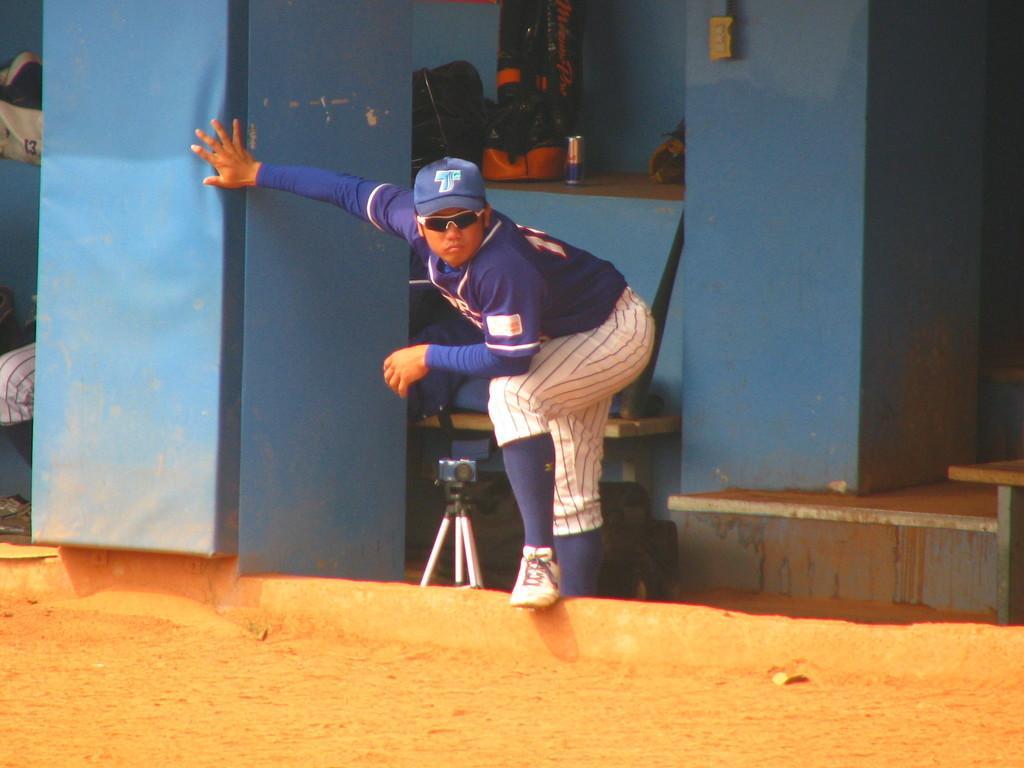Please provide a concise description of this image. In this image there is a man standing in the middle. He is wearing the jersey and a cap. Beside him there is a camera on the tripod. In the background there is a wall on which there is a soft drink tin. Beside it, It looks like a bag. At the bottom there is sand. On the left side there is another person who is sitting on the bench. On the left side top there is a bag. On the right side it looks like a table. 